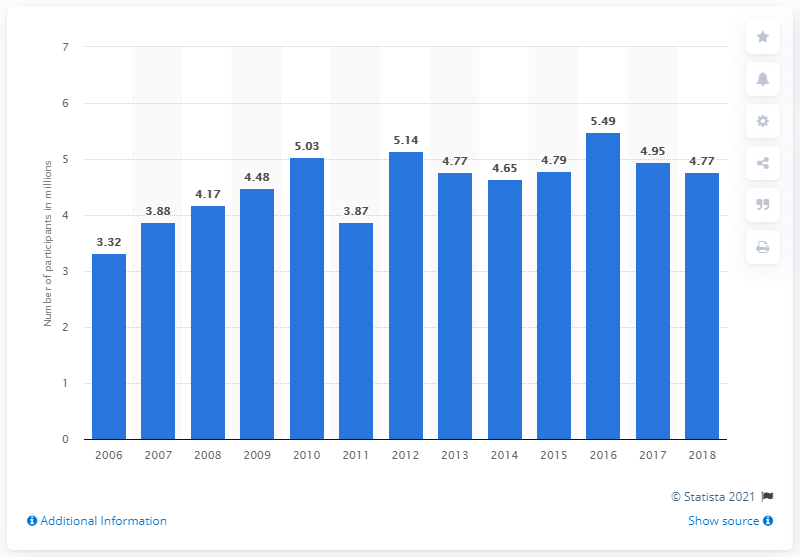List a handful of essential elements in this visual. According to the data, in 2018, there were a total of 4,770 participants in beach volleyball. 